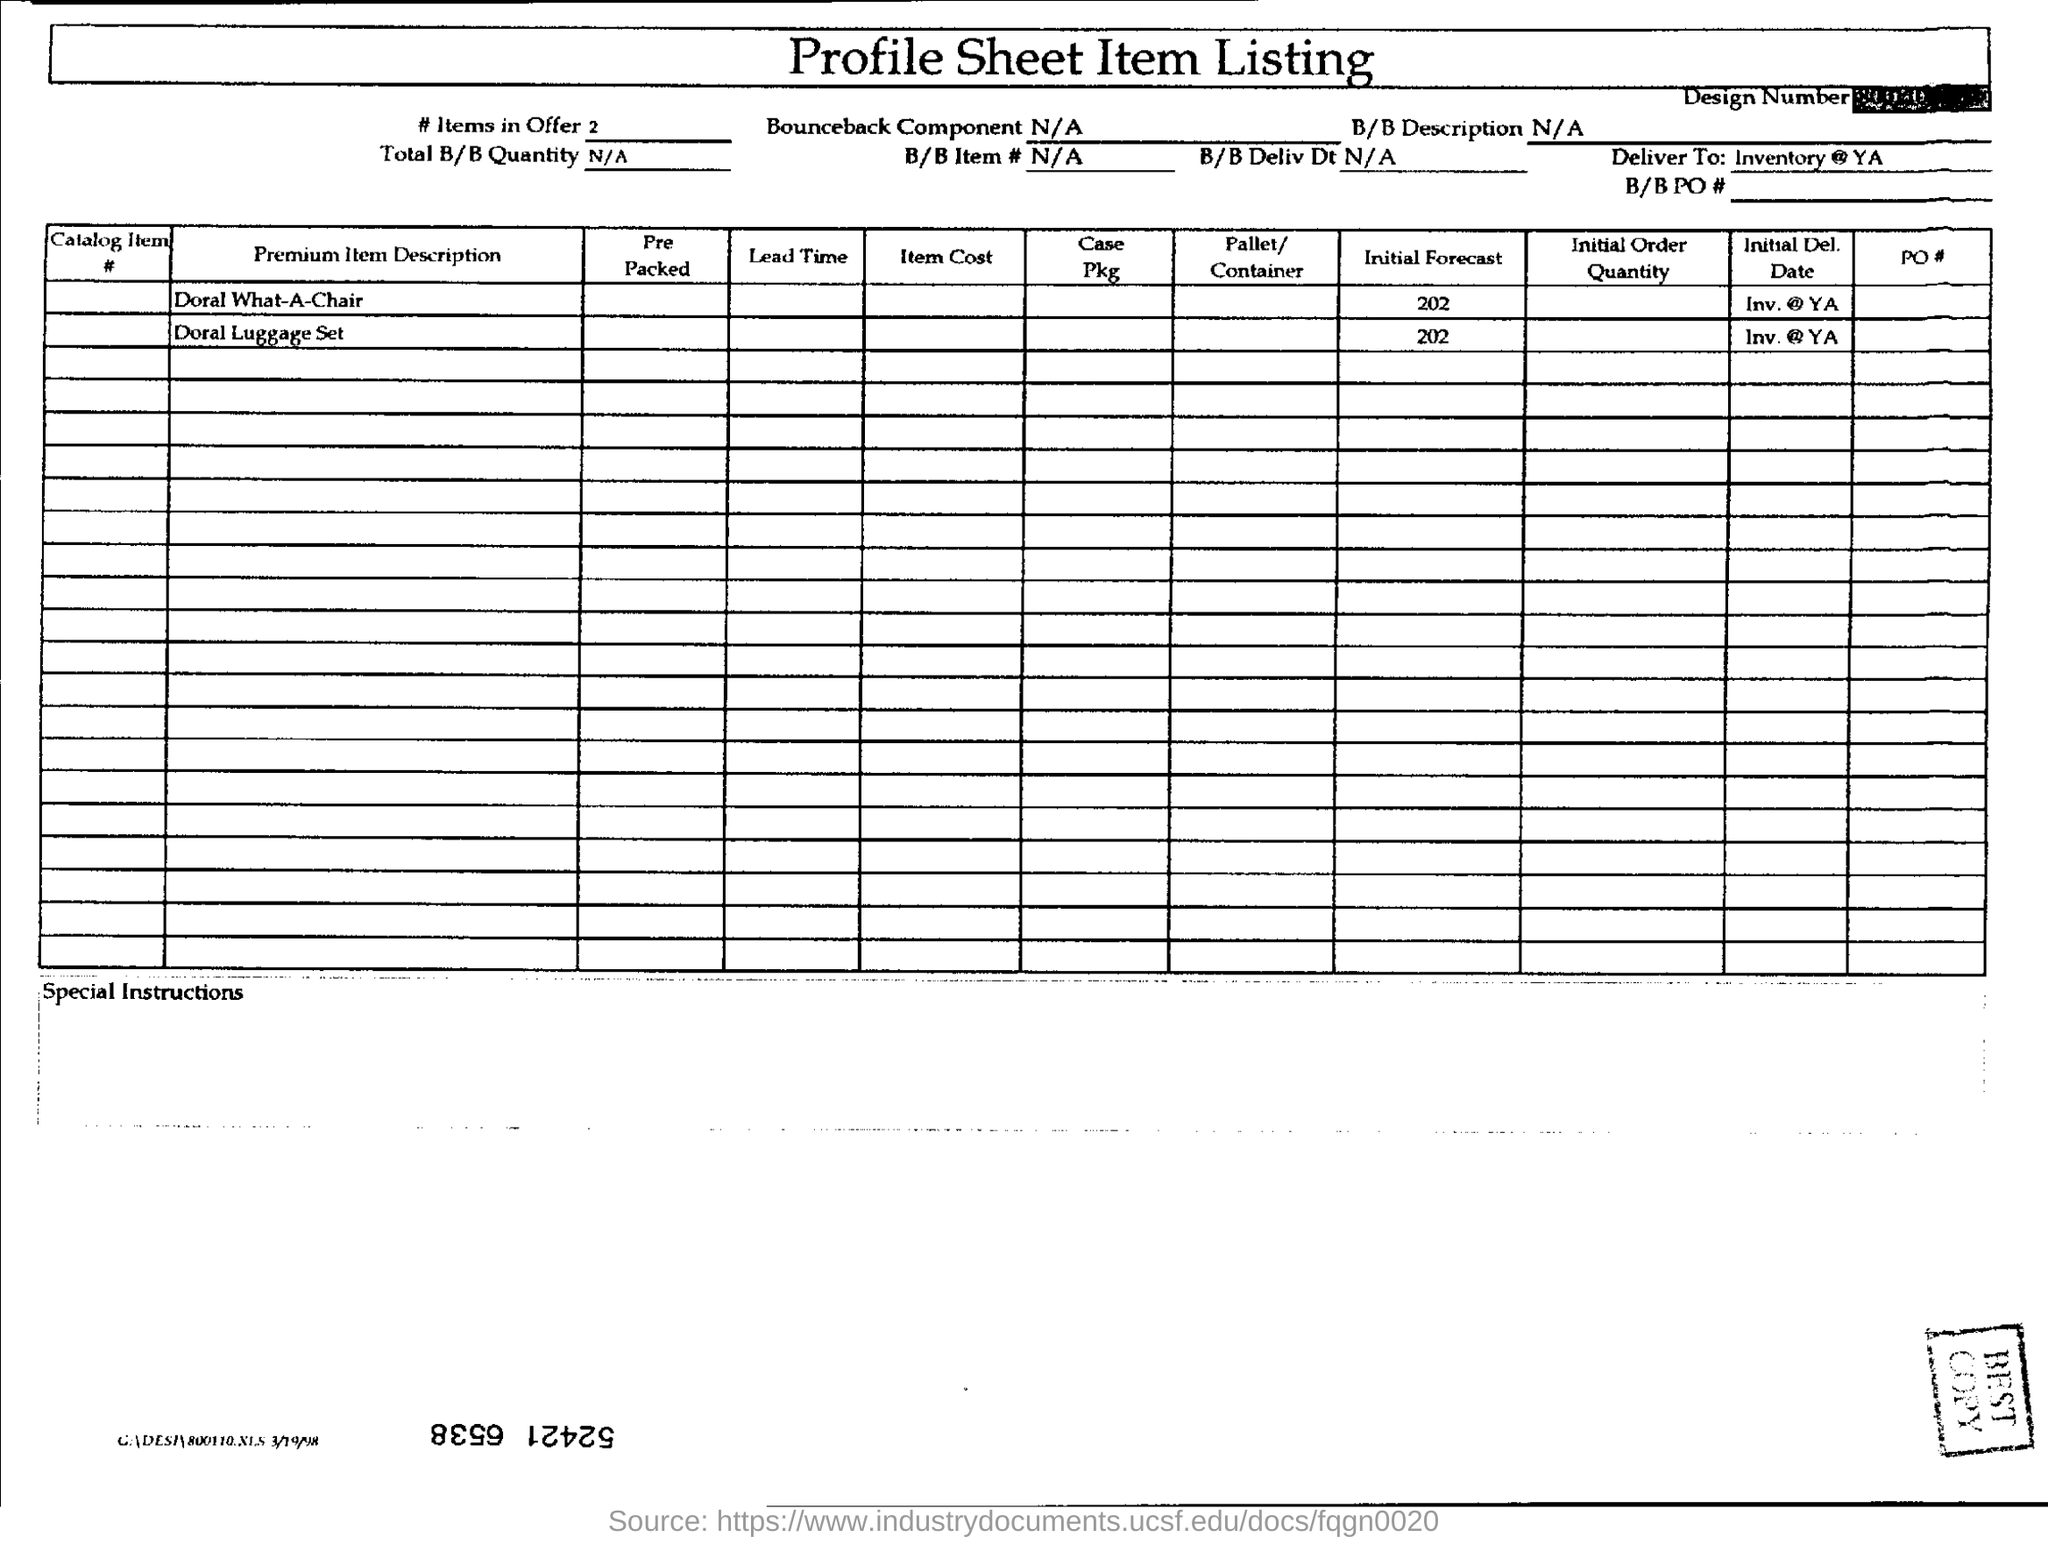What is the title of this document
Provide a short and direct response. Profile sheet item listing. 